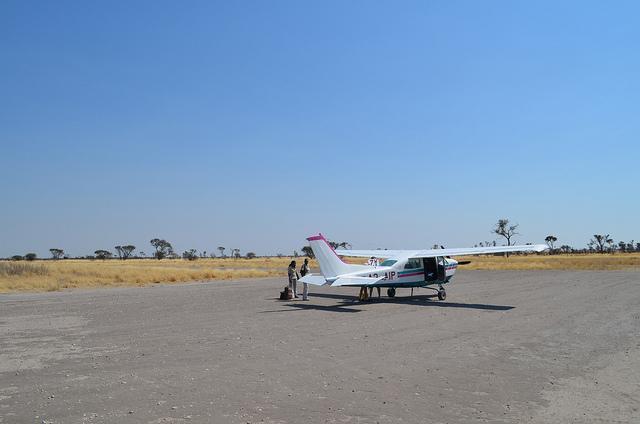What biome is in the background?
Pick the right solution, then justify: 'Answer: answer
Rationale: rationale.'
Options: Desert, tundra, rainforest, savanna. Answer: savanna.
Rationale: Just like in the plains of africa the lack of trees and tall grass lets you know what type if region they are in. 